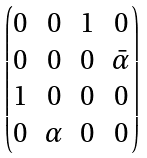<formula> <loc_0><loc_0><loc_500><loc_500>\begin{pmatrix} 0 & 0 & 1 & 0 \\ 0 & 0 & 0 & \bar { \alpha } \\ 1 & 0 & 0 & 0 \\ 0 & \alpha & 0 & 0 \end{pmatrix}</formula> 